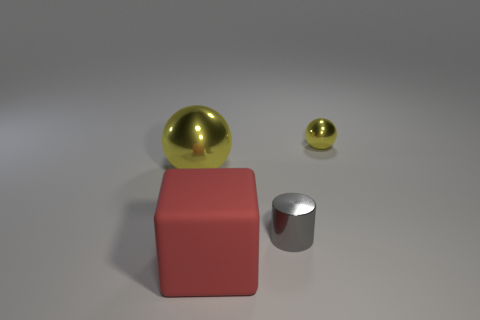Add 1 green cylinders. How many objects exist? 5 Subtract all cubes. How many objects are left? 3 Subtract all large brown metallic things. Subtract all red matte things. How many objects are left? 3 Add 4 large red objects. How many large red objects are left? 5 Add 1 gray metal cylinders. How many gray metal cylinders exist? 2 Subtract 0 purple cylinders. How many objects are left? 4 